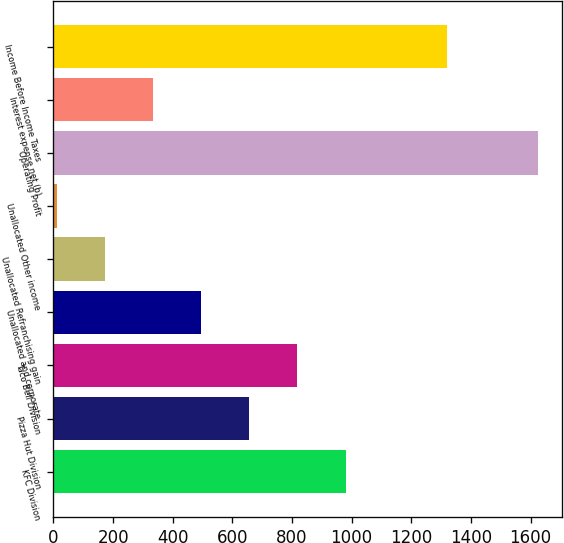<chart> <loc_0><loc_0><loc_500><loc_500><bar_chart><fcel>KFC Division<fcel>Pizza Hut Division<fcel>Taco Bell Division<fcel>Unallocated and corporate<fcel>Unallocated Refranchising gain<fcel>Unallocated Other income<fcel>Operating Profit<fcel>Interest expense net (b)<fcel>Income Before Income Taxes<nl><fcel>979.4<fcel>656.6<fcel>818<fcel>495.2<fcel>172.4<fcel>11<fcel>1625<fcel>333.8<fcel>1318<nl></chart> 